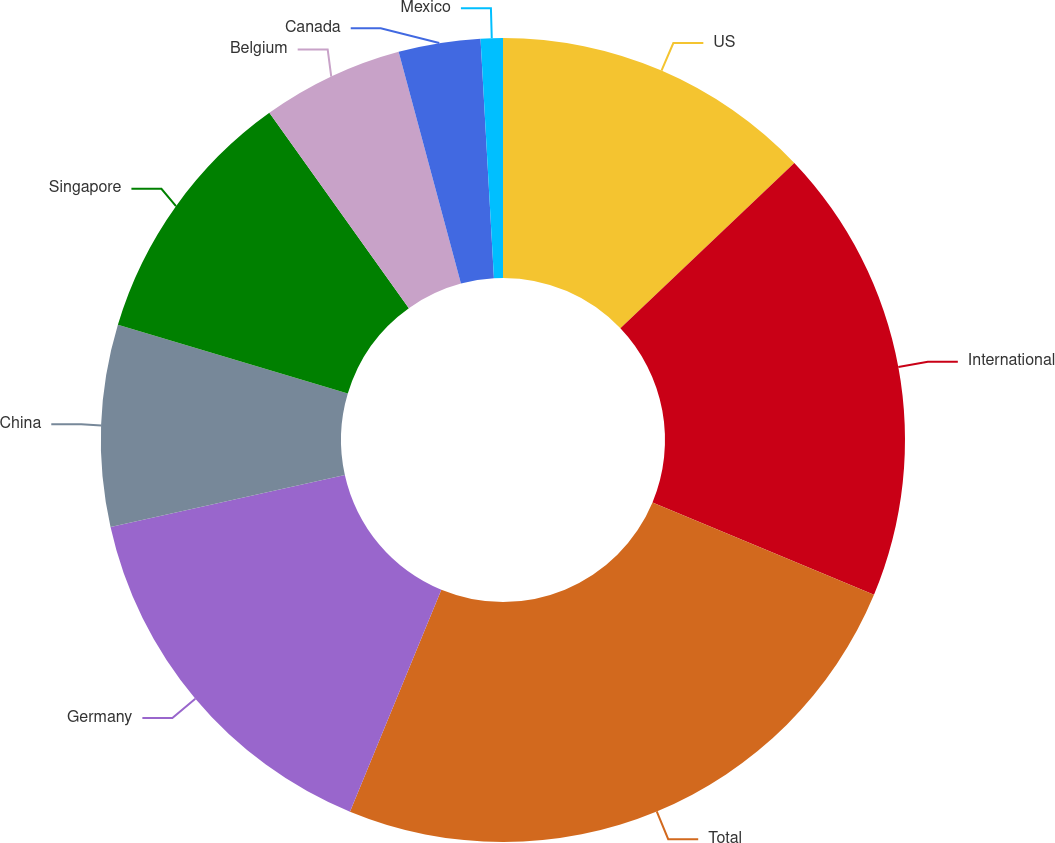Convert chart to OTSL. <chart><loc_0><loc_0><loc_500><loc_500><pie_chart><fcel>US<fcel>International<fcel>Total<fcel>Germany<fcel>China<fcel>Singapore<fcel>Belgium<fcel>Canada<fcel>Mexico<nl><fcel>12.9%<fcel>18.39%<fcel>24.92%<fcel>15.31%<fcel>8.1%<fcel>10.5%<fcel>5.69%<fcel>3.29%<fcel>0.89%<nl></chart> 